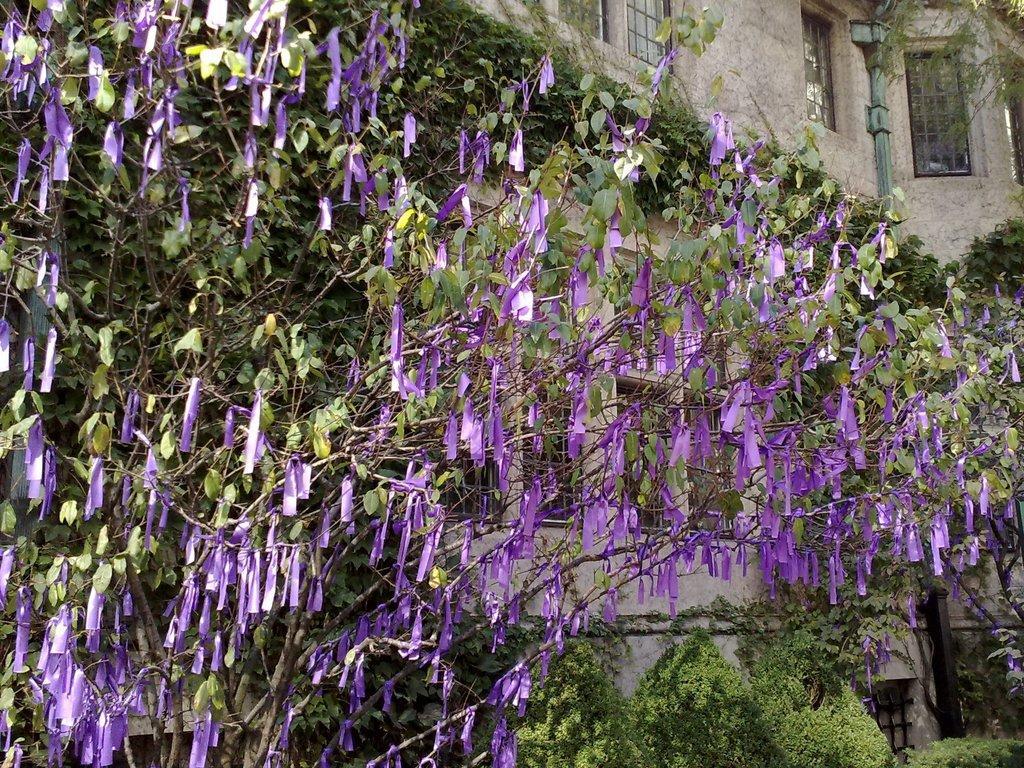In one or two sentences, can you explain what this image depicts? In this image , in the foreground we see green leaves with purple flower and in the background there is a house. 